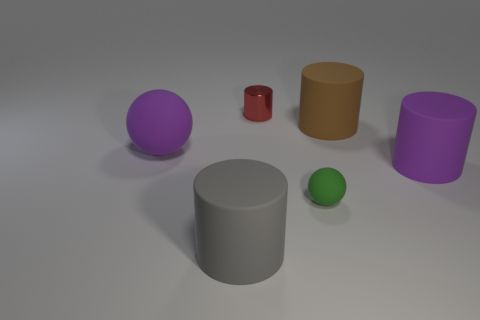Subtract all large matte cylinders. How many cylinders are left? 1 Add 3 tiny gray rubber cylinders. How many objects exist? 9 Subtract all green balls. How many balls are left? 1 Subtract all cylinders. How many objects are left? 2 Add 1 metallic cylinders. How many metallic cylinders are left? 2 Add 4 rubber cylinders. How many rubber cylinders exist? 7 Subtract 0 cyan cylinders. How many objects are left? 6 Subtract 1 cylinders. How many cylinders are left? 3 Subtract all green spheres. Subtract all yellow cubes. How many spheres are left? 1 Subtract all big rubber spheres. Subtract all small purple spheres. How many objects are left? 5 